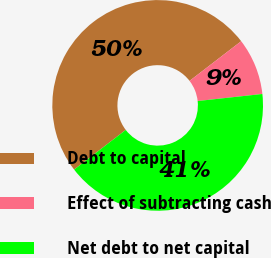Convert chart. <chart><loc_0><loc_0><loc_500><loc_500><pie_chart><fcel>Debt to capital<fcel>Effect of subtracting cash<fcel>Net debt to net capital<nl><fcel>50.0%<fcel>8.7%<fcel>41.3%<nl></chart> 